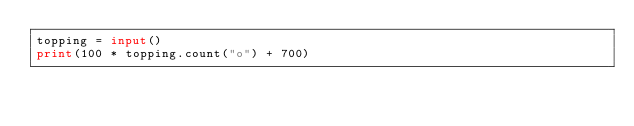Convert code to text. <code><loc_0><loc_0><loc_500><loc_500><_Python_>topping = input()
print(100 * topping.count("o") + 700)</code> 